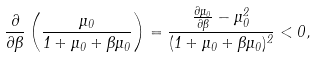<formula> <loc_0><loc_0><loc_500><loc_500>\frac { \partial } { \partial \beta } \left ( \frac { \mu _ { 0 } } { 1 + \mu _ { 0 } + \beta \mu _ { 0 } } \right ) = \frac { \frac { \partial \mu _ { 0 } } { \partial \beta } - \mu _ { 0 } ^ { 2 } } { ( 1 + \mu _ { 0 } + \beta \mu _ { 0 } ) ^ { 2 } } < 0 ,</formula> 